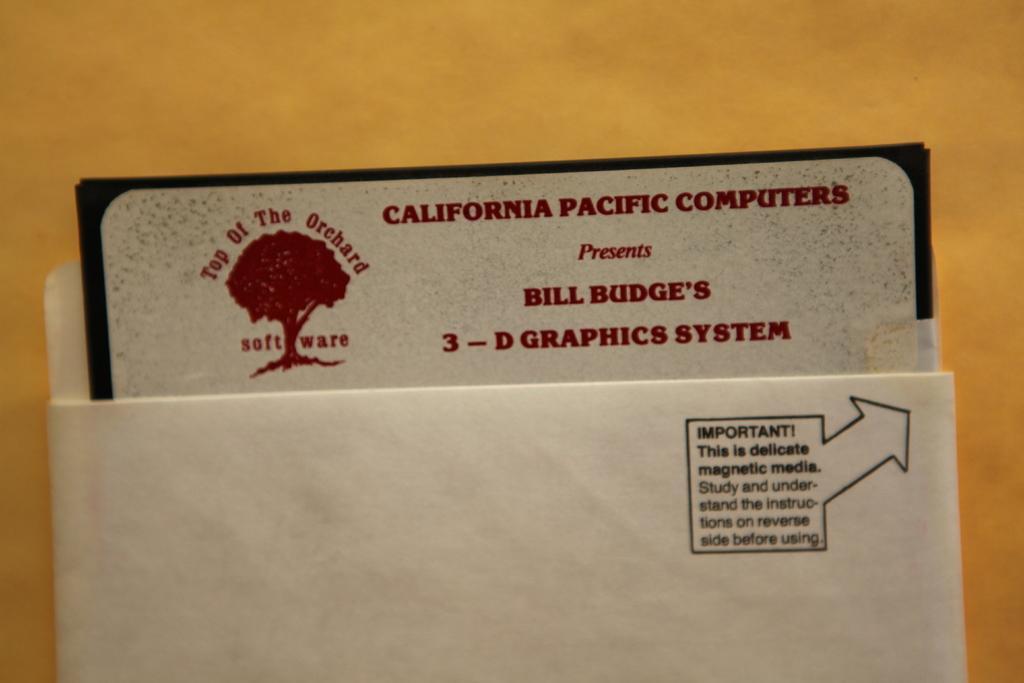What kind of graphics system is this?
Your answer should be compact. 3-d. What company made the software?
Provide a succinct answer. California pacific computers. 